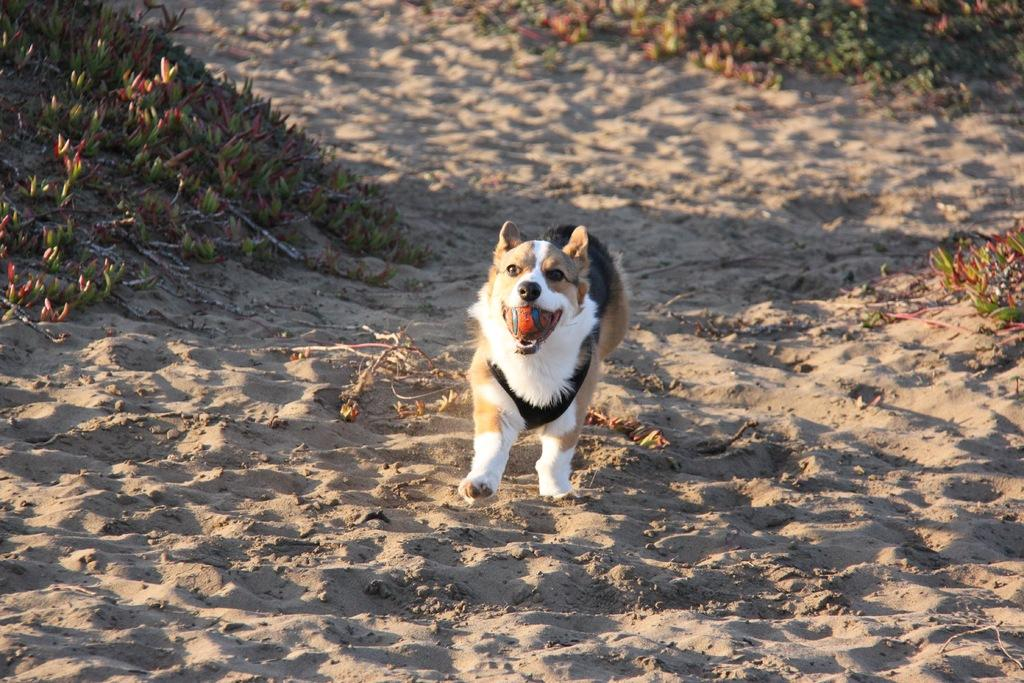What type of animal is in the image? There is a dog in the image. What colors can be seen on the dog? The dog has white, brown, and black colors. Where is the dog located in the image? The dog is on the sand. What type of vegetation is visible in the image? There is grass visible in the image. Can you see any volcanoes in the image? No, there are no volcanoes present in the image. What type of metal object is being used by the dog in the image? There is no metal object being used by the dog in the image. 